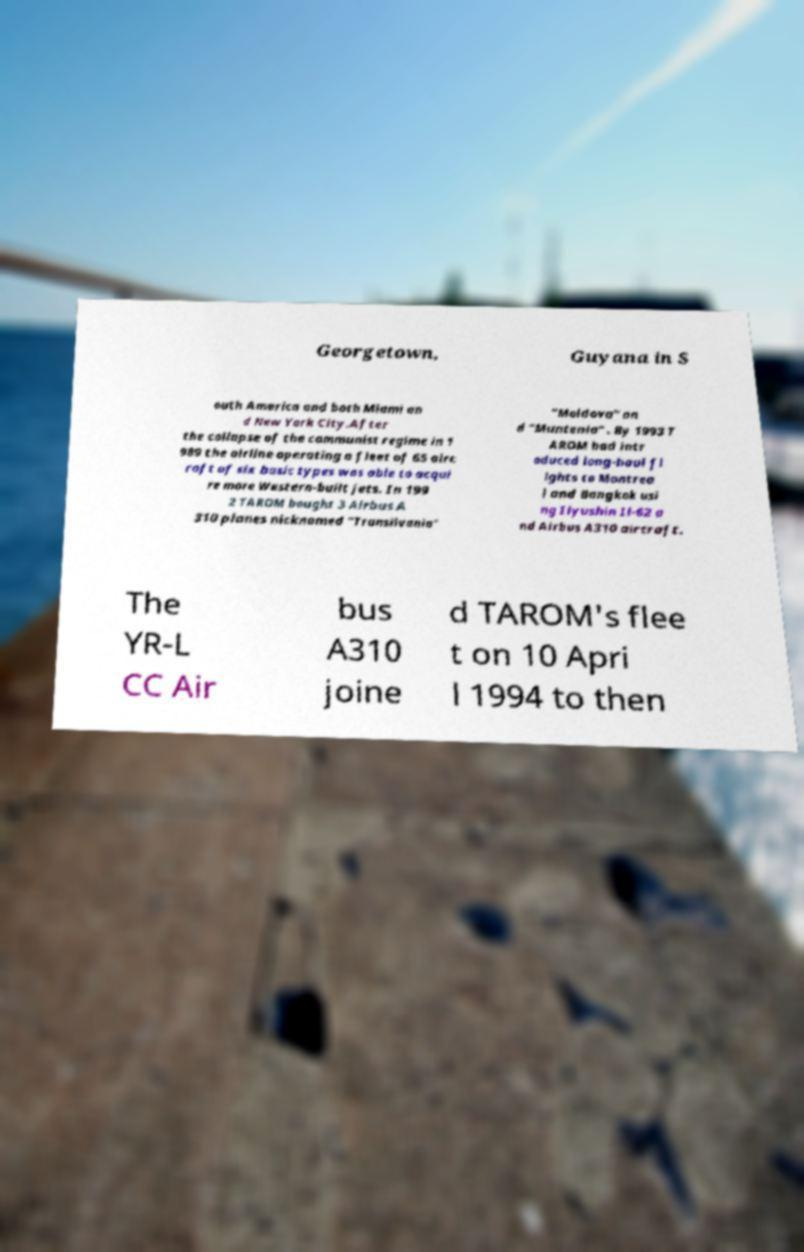What messages or text are displayed in this image? I need them in a readable, typed format. Georgetown, Guyana in S outh America and both Miami an d New York City.After the collapse of the communist regime in 1 989 the airline operating a fleet of 65 airc raft of six basic types was able to acqui re more Western-built jets. In 199 2 TAROM bought 3 Airbus A 310 planes nicknamed "Transilvania" "Moldova" an d "Muntenia" . By 1993 T AROM had intr oduced long-haul fl ights to Montrea l and Bangkok usi ng Ilyushin Il-62 a nd Airbus A310 aircraft. The YR-L CC Air bus A310 joine d TAROM's flee t on 10 Apri l 1994 to then 